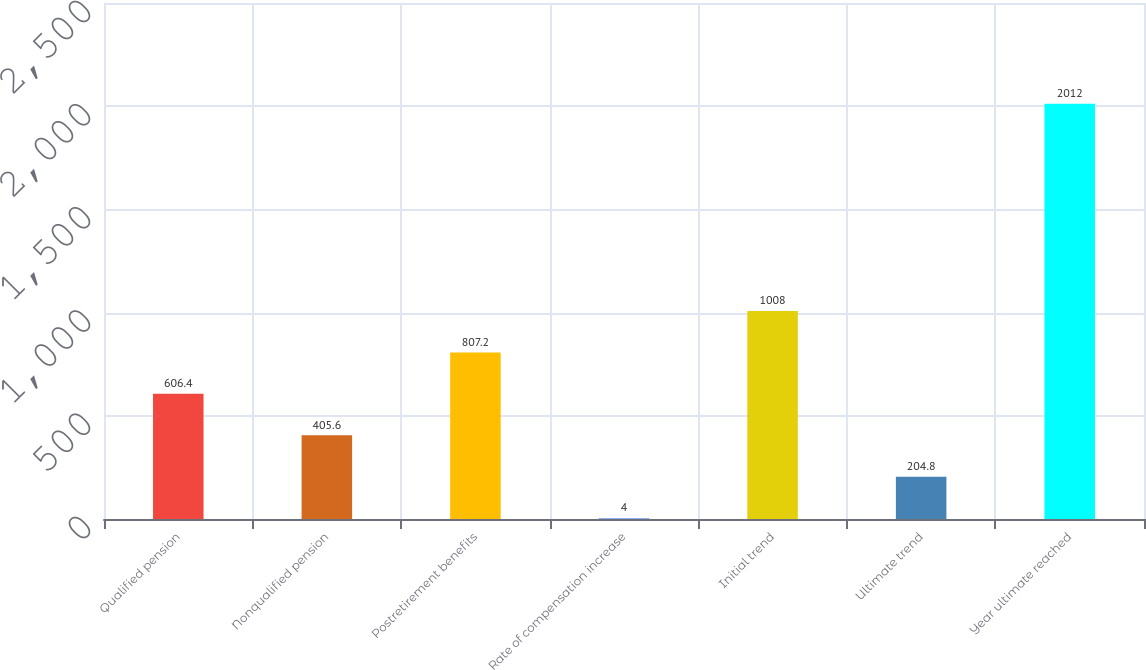Convert chart to OTSL. <chart><loc_0><loc_0><loc_500><loc_500><bar_chart><fcel>Qualified pension<fcel>Nonqualified pension<fcel>Postretirement benefits<fcel>Rate of compensation increase<fcel>Initial trend<fcel>Ultimate trend<fcel>Year ultimate reached<nl><fcel>606.4<fcel>405.6<fcel>807.2<fcel>4<fcel>1008<fcel>204.8<fcel>2012<nl></chart> 